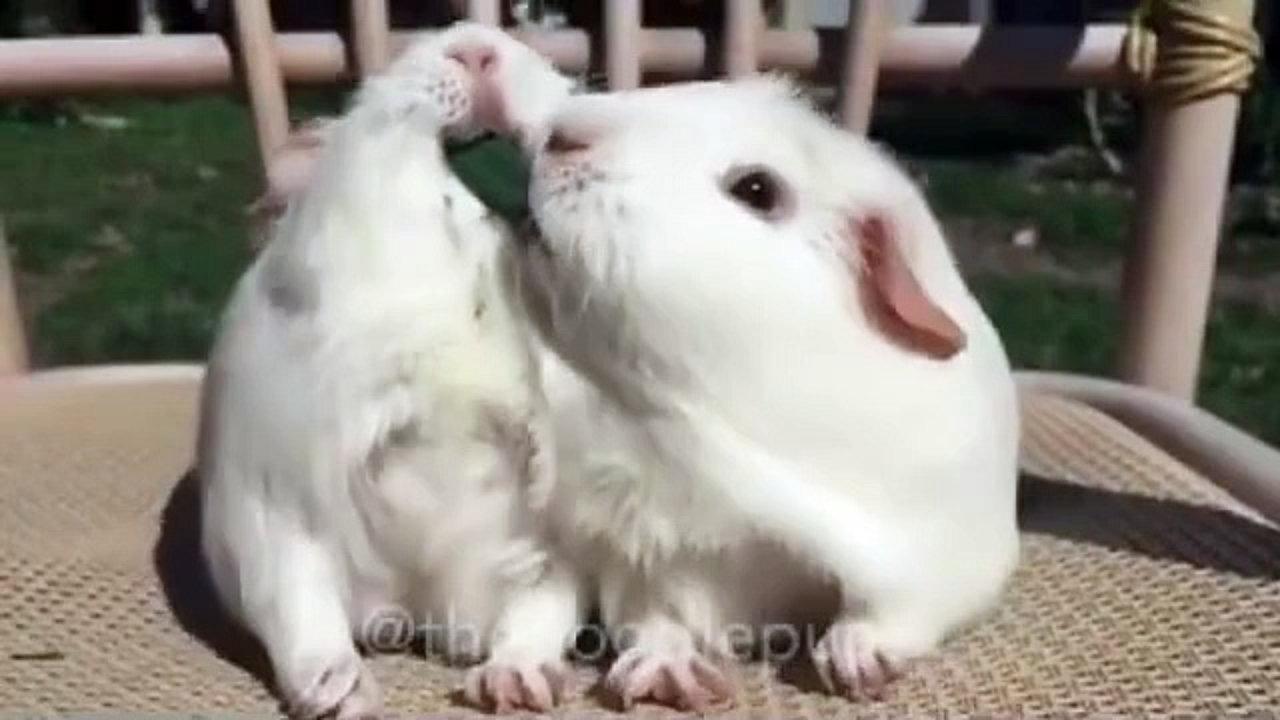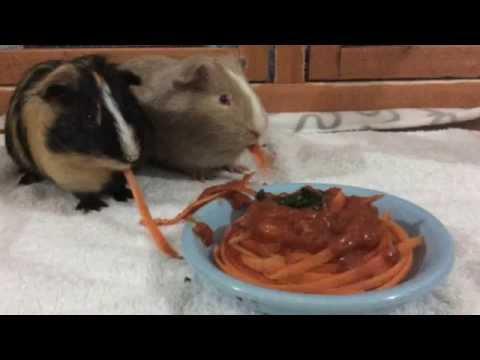The first image is the image on the left, the second image is the image on the right. Examine the images to the left and right. Is the description "A rodent is eating pasta in the left image." accurate? Answer yes or no. No. The first image is the image on the left, the second image is the image on the right. Given the left and right images, does the statement "The rodent in the image on the left sits on a surface to eat noodles." hold true? Answer yes or no. No. 